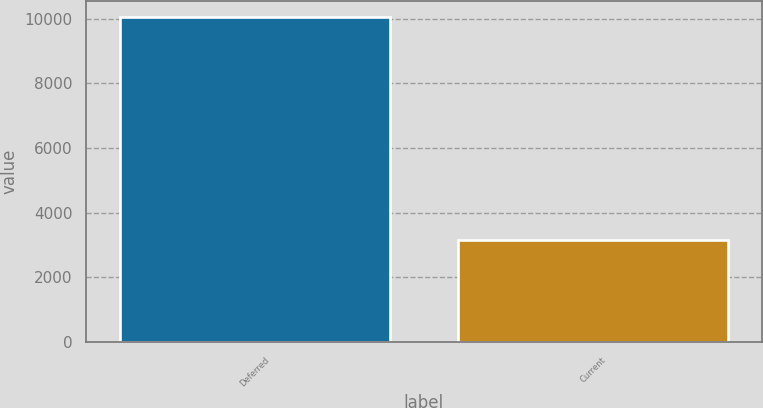Convert chart. <chart><loc_0><loc_0><loc_500><loc_500><bar_chart><fcel>Deferred<fcel>Current<nl><fcel>10034<fcel>3146<nl></chart> 